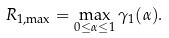<formula> <loc_0><loc_0><loc_500><loc_500>R _ { 1 , \max } = \max _ { 0 \leq \alpha \leq 1 } \gamma _ { 1 } ( \alpha ) .</formula> 